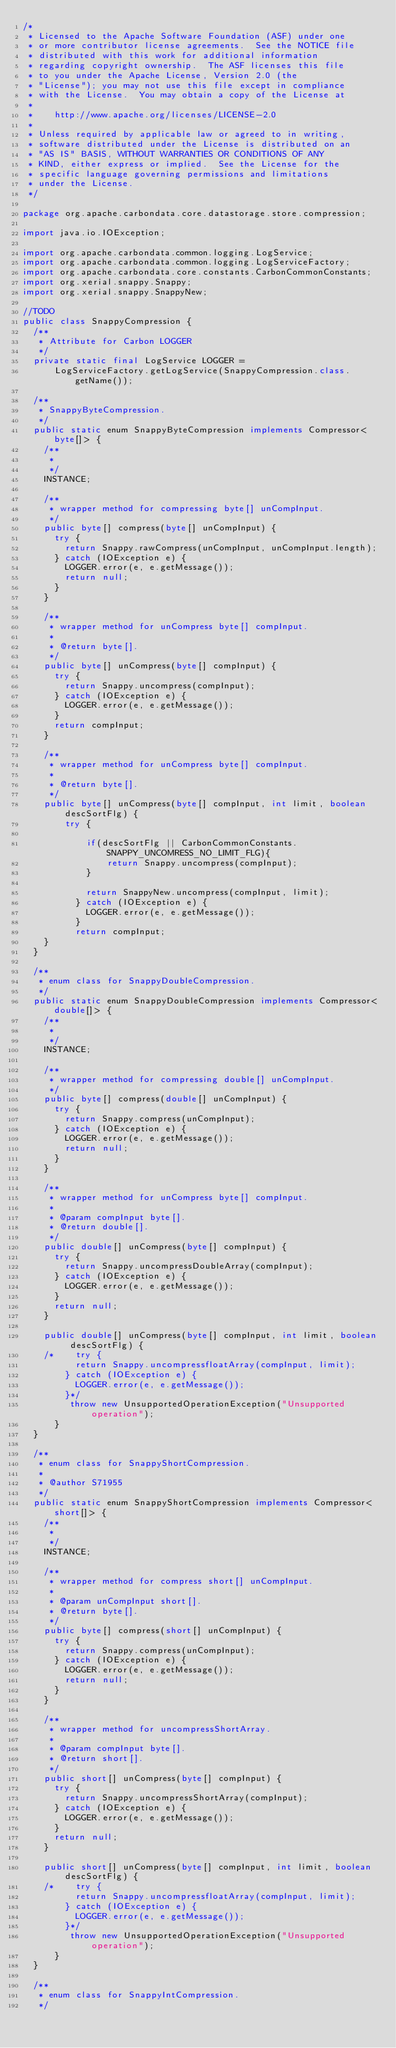Convert code to text. <code><loc_0><loc_0><loc_500><loc_500><_Java_>/*
 * Licensed to the Apache Software Foundation (ASF) under one
 * or more contributor license agreements.  See the NOTICE file
 * distributed with this work for additional information
 * regarding copyright ownership.  The ASF licenses this file
 * to you under the Apache License, Version 2.0 (the
 * "License"); you may not use this file except in compliance
 * with the License.  You may obtain a copy of the License at
 *
 *    http://www.apache.org/licenses/LICENSE-2.0
 *
 * Unless required by applicable law or agreed to in writing,
 * software distributed under the License is distributed on an
 * "AS IS" BASIS, WITHOUT WARRANTIES OR CONDITIONS OF ANY
 * KIND, either express or implied.  See the License for the
 * specific language governing permissions and limitations
 * under the License.
 */

package org.apache.carbondata.core.datastorage.store.compression;

import java.io.IOException;

import org.apache.carbondata.common.logging.LogService;
import org.apache.carbondata.common.logging.LogServiceFactory;
import org.apache.carbondata.core.constants.CarbonCommonConstants;
import org.xerial.snappy.Snappy;
import org.xerial.snappy.SnappyNew;

//TODO
public class SnappyCompression {
  /**
   * Attribute for Carbon LOGGER
   */
  private static final LogService LOGGER =
      LogServiceFactory.getLogService(SnappyCompression.class.getName());

  /**
   * SnappyByteCompression.
   */
  public static enum SnappyByteCompression implements Compressor<byte[]> {
    /**
     *
     */
    INSTANCE;

    /**
     * wrapper method for compressing byte[] unCompInput.
     */
    public byte[] compress(byte[] unCompInput) {
      try {
        return Snappy.rawCompress(unCompInput, unCompInput.length);
      } catch (IOException e) {
        LOGGER.error(e, e.getMessage());
        return null;
      }
    }

    /**
     * wrapper method for unCompress byte[] compInput.
     *
     * @return byte[].
     */
    public byte[] unCompress(byte[] compInput) {
      try {
        return Snappy.uncompress(compInput);
      } catch (IOException e) {
        LOGGER.error(e, e.getMessage());
      }
      return compInput;
    }
    
    /**
     * wrapper method for unCompress byte[] compInput.
     *
     * @return byte[].
     */
    public byte[] unCompress(byte[] compInput, int limit, boolean descSortFlg) {
        try {
        	
        	if(descSortFlg || CarbonCommonConstants.SNAPPY_UNCOMRESS_NO_LIMIT_FLG){
        		return Snappy.uncompress(compInput);
        	}
        	
            return SnappyNew.uncompress(compInput, limit);
          } catch (IOException e) {
            LOGGER.error(e, e.getMessage());
          }
          return compInput;
    }
  }

  /**
   * enum class for SnappyDoubleCompression.
   */
  public static enum SnappyDoubleCompression implements Compressor<double[]> {
    /**
     *
     */
    INSTANCE;

    /**
     * wrapper method for compressing double[] unCompInput.
     */
    public byte[] compress(double[] unCompInput) {
      try {
        return Snappy.compress(unCompInput);
      } catch (IOException e) {
        LOGGER.error(e, e.getMessage());
        return null;
      }
    }

    /**
     * wrapper method for unCompress byte[] compInput.
     *
     * @param compInput byte[].
     * @return double[].
     */
    public double[] unCompress(byte[] compInput) {
      try {
        return Snappy.uncompressDoubleArray(compInput);
      } catch (IOException e) {
        LOGGER.error(e, e.getMessage());
      }
      return null;
    }
    
    public double[] unCompress(byte[] compInput, int limit, boolean descSortFlg) {
    /*    try {
          return Snappy.uncompressfloatArray(compInput, limit);
        } catch (IOException e) {
          LOGGER.error(e, e.getMessage());
        }*/
    	 throw new UnsupportedOperationException("Unsupported operation");
      }
  }

  /**
   * enum class for SnappyShortCompression.
   *
   * @author S71955
   */
  public static enum SnappyShortCompression implements Compressor<short[]> {
    /**
     *
     */
    INSTANCE;

    /**
     * wrapper method for compress short[] unCompInput.
     *
     * @param unCompInput short[].
     * @return byte[].
     */
    public byte[] compress(short[] unCompInput) {
      try {
        return Snappy.compress(unCompInput);
      } catch (IOException e) {
        LOGGER.error(e, e.getMessage());
        return null;
      }
    }

    /**
     * wrapper method for uncompressShortArray.
     *
     * @param compInput byte[].
     * @return short[].
     */
    public short[] unCompress(byte[] compInput) {
      try {
        return Snappy.uncompressShortArray(compInput);
      } catch (IOException e) {
        LOGGER.error(e, e.getMessage());
      }
      return null;
    }
    
    public short[] unCompress(byte[] compInput, int limit, boolean descSortFlg) {
    /*    try {
          return Snappy.uncompressfloatArray(compInput, limit);
        } catch (IOException e) {
          LOGGER.error(e, e.getMessage());
        }*/
    	 throw new UnsupportedOperationException("Unsupported operation");
      }
  }

  /**
   * enum class for SnappyIntCompression.
   */</code> 